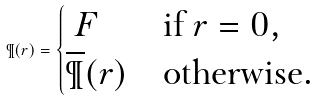Convert formula to latex. <formula><loc_0><loc_0><loc_500><loc_500>\P ( r ) = \begin{cases} \ F & \text {if $r=0$} , \\ \overline { \P } ( r ) & \text {otherwise} . \end{cases}</formula> 